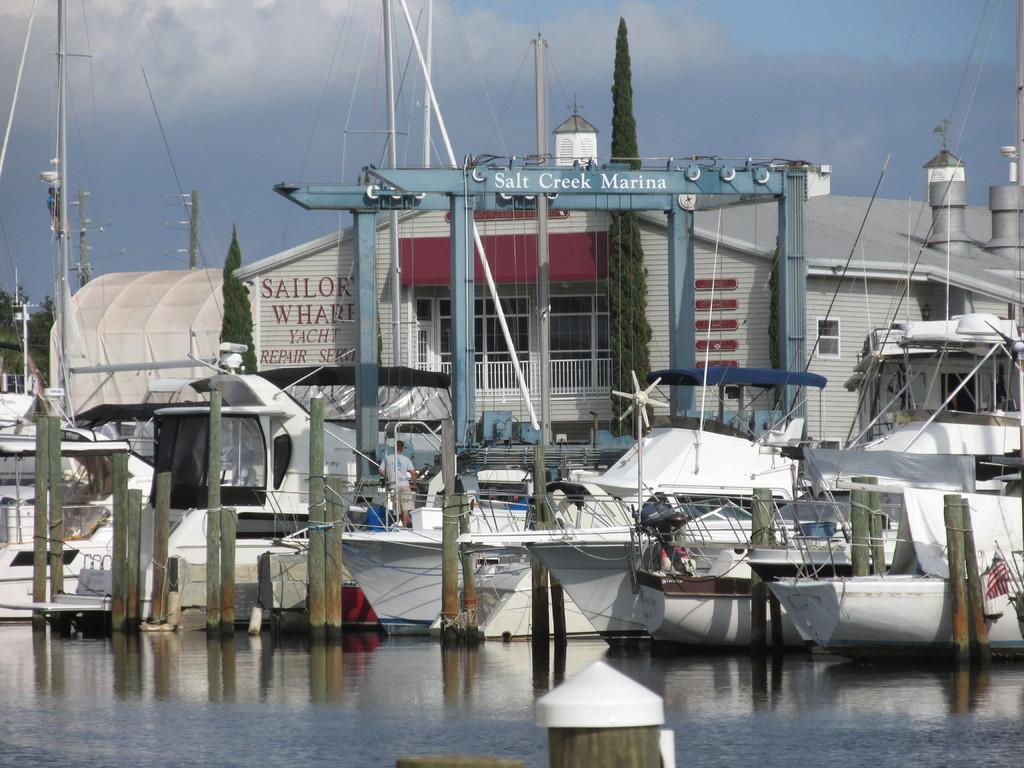<image>
Write a terse but informative summary of the picture. A row of boats are moored at the Salt Creek Marina. 